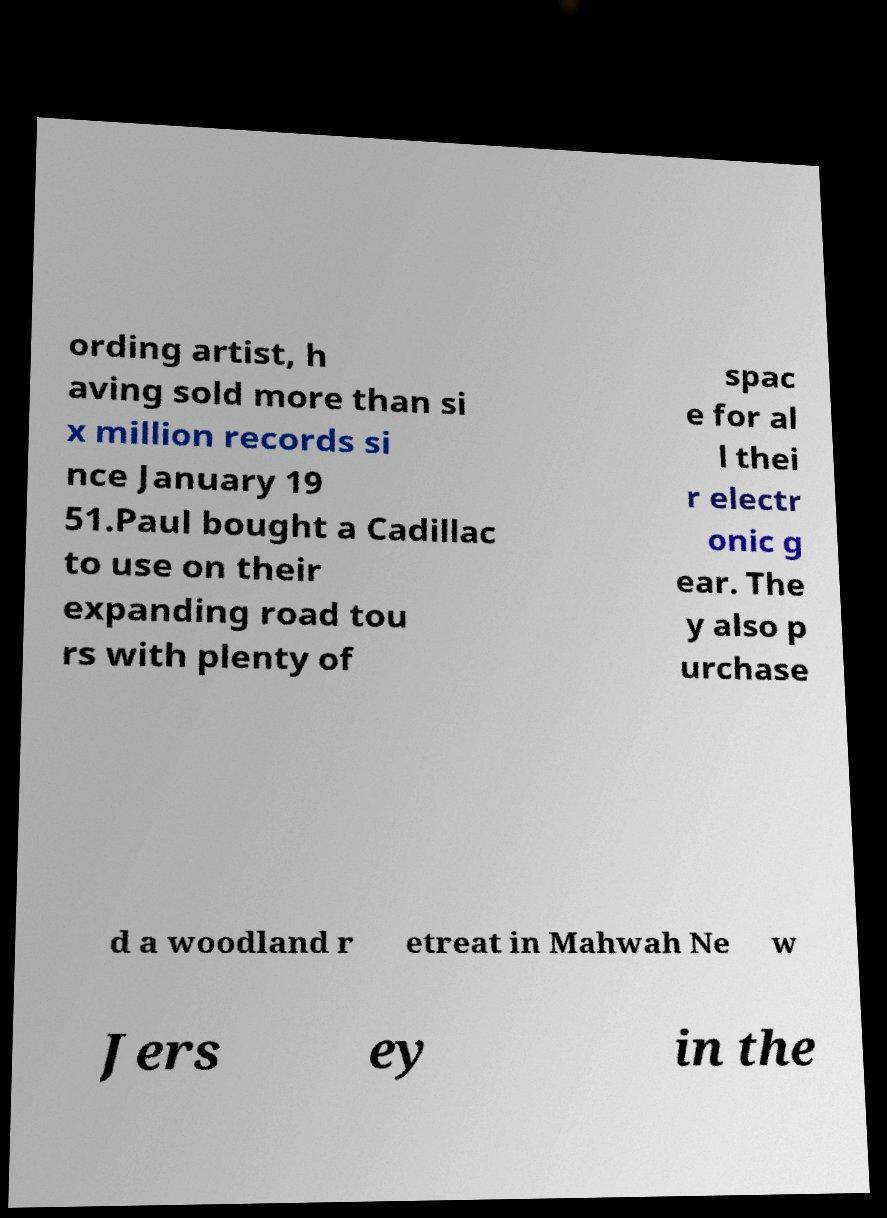Could you extract and type out the text from this image? ording artist, h aving sold more than si x million records si nce January 19 51.Paul bought a Cadillac to use on their expanding road tou rs with plenty of spac e for al l thei r electr onic g ear. The y also p urchase d a woodland r etreat in Mahwah Ne w Jers ey in the 